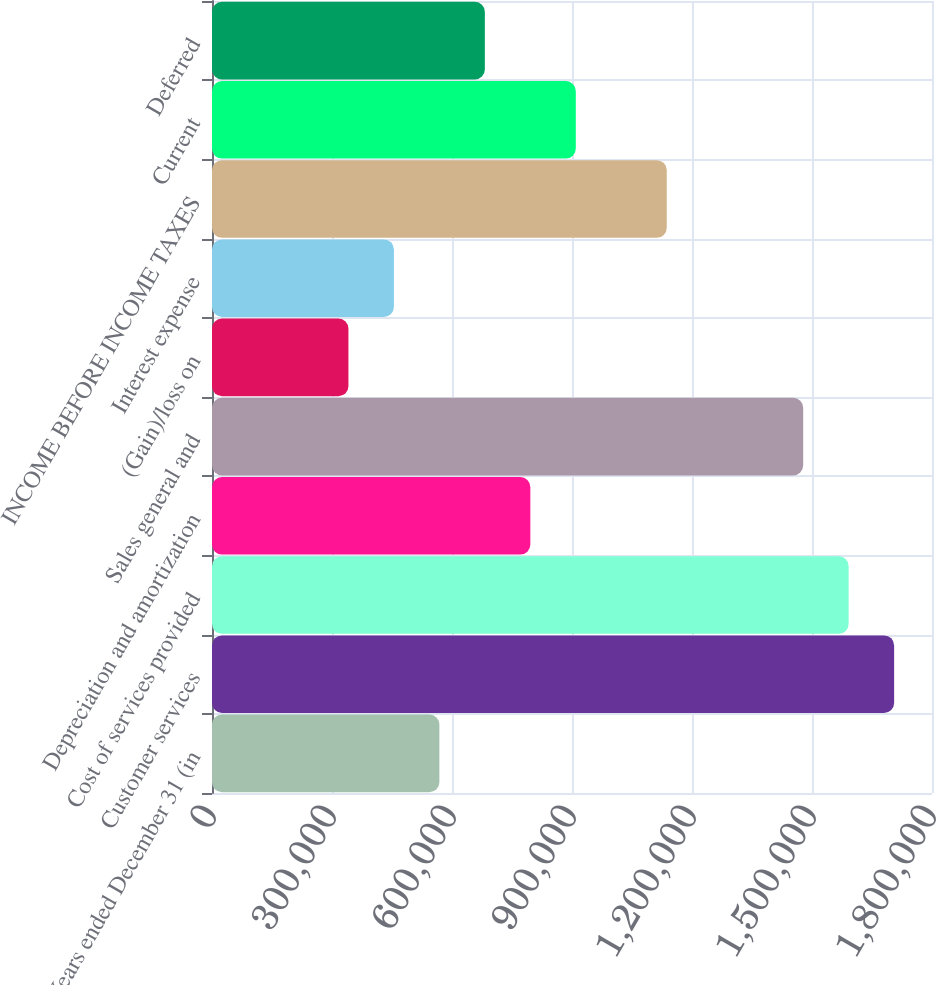Convert chart to OTSL. <chart><loc_0><loc_0><loc_500><loc_500><bar_chart><fcel>Years ended December 31 (in<fcel>Customer services<fcel>Cost of services provided<fcel>Depreciation and amortization<fcel>Sales general and<fcel>(Gain)/loss on<fcel>Interest expense<fcel>INCOME BEFORE INCOME TAXES<fcel>Current<fcel>Deferred<nl><fcel>568445<fcel>1.70533e+06<fcel>1.59165e+06<fcel>795823<fcel>1.47796e+06<fcel>341067<fcel>454756<fcel>1.13689e+06<fcel>909512<fcel>682134<nl></chart> 